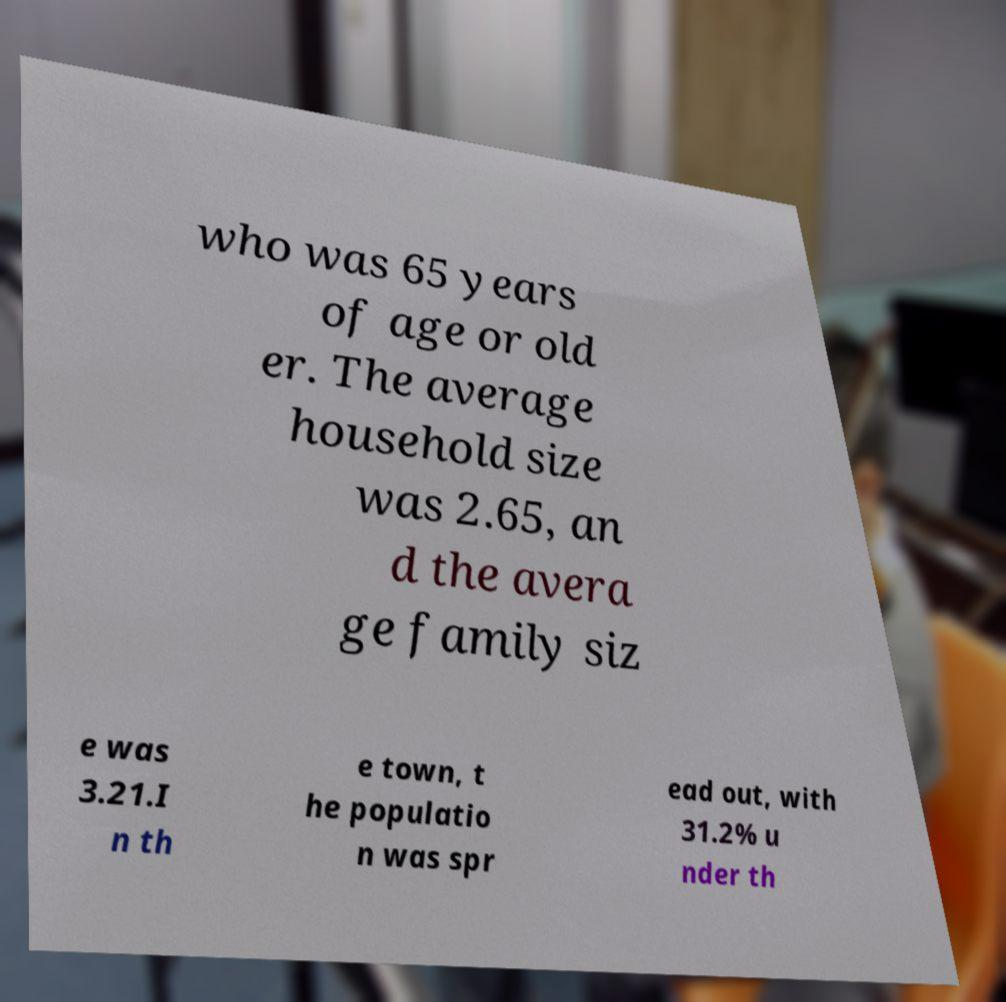There's text embedded in this image that I need extracted. Can you transcribe it verbatim? who was 65 years of age or old er. The average household size was 2.65, an d the avera ge family siz e was 3.21.I n th e town, t he populatio n was spr ead out, with 31.2% u nder th 